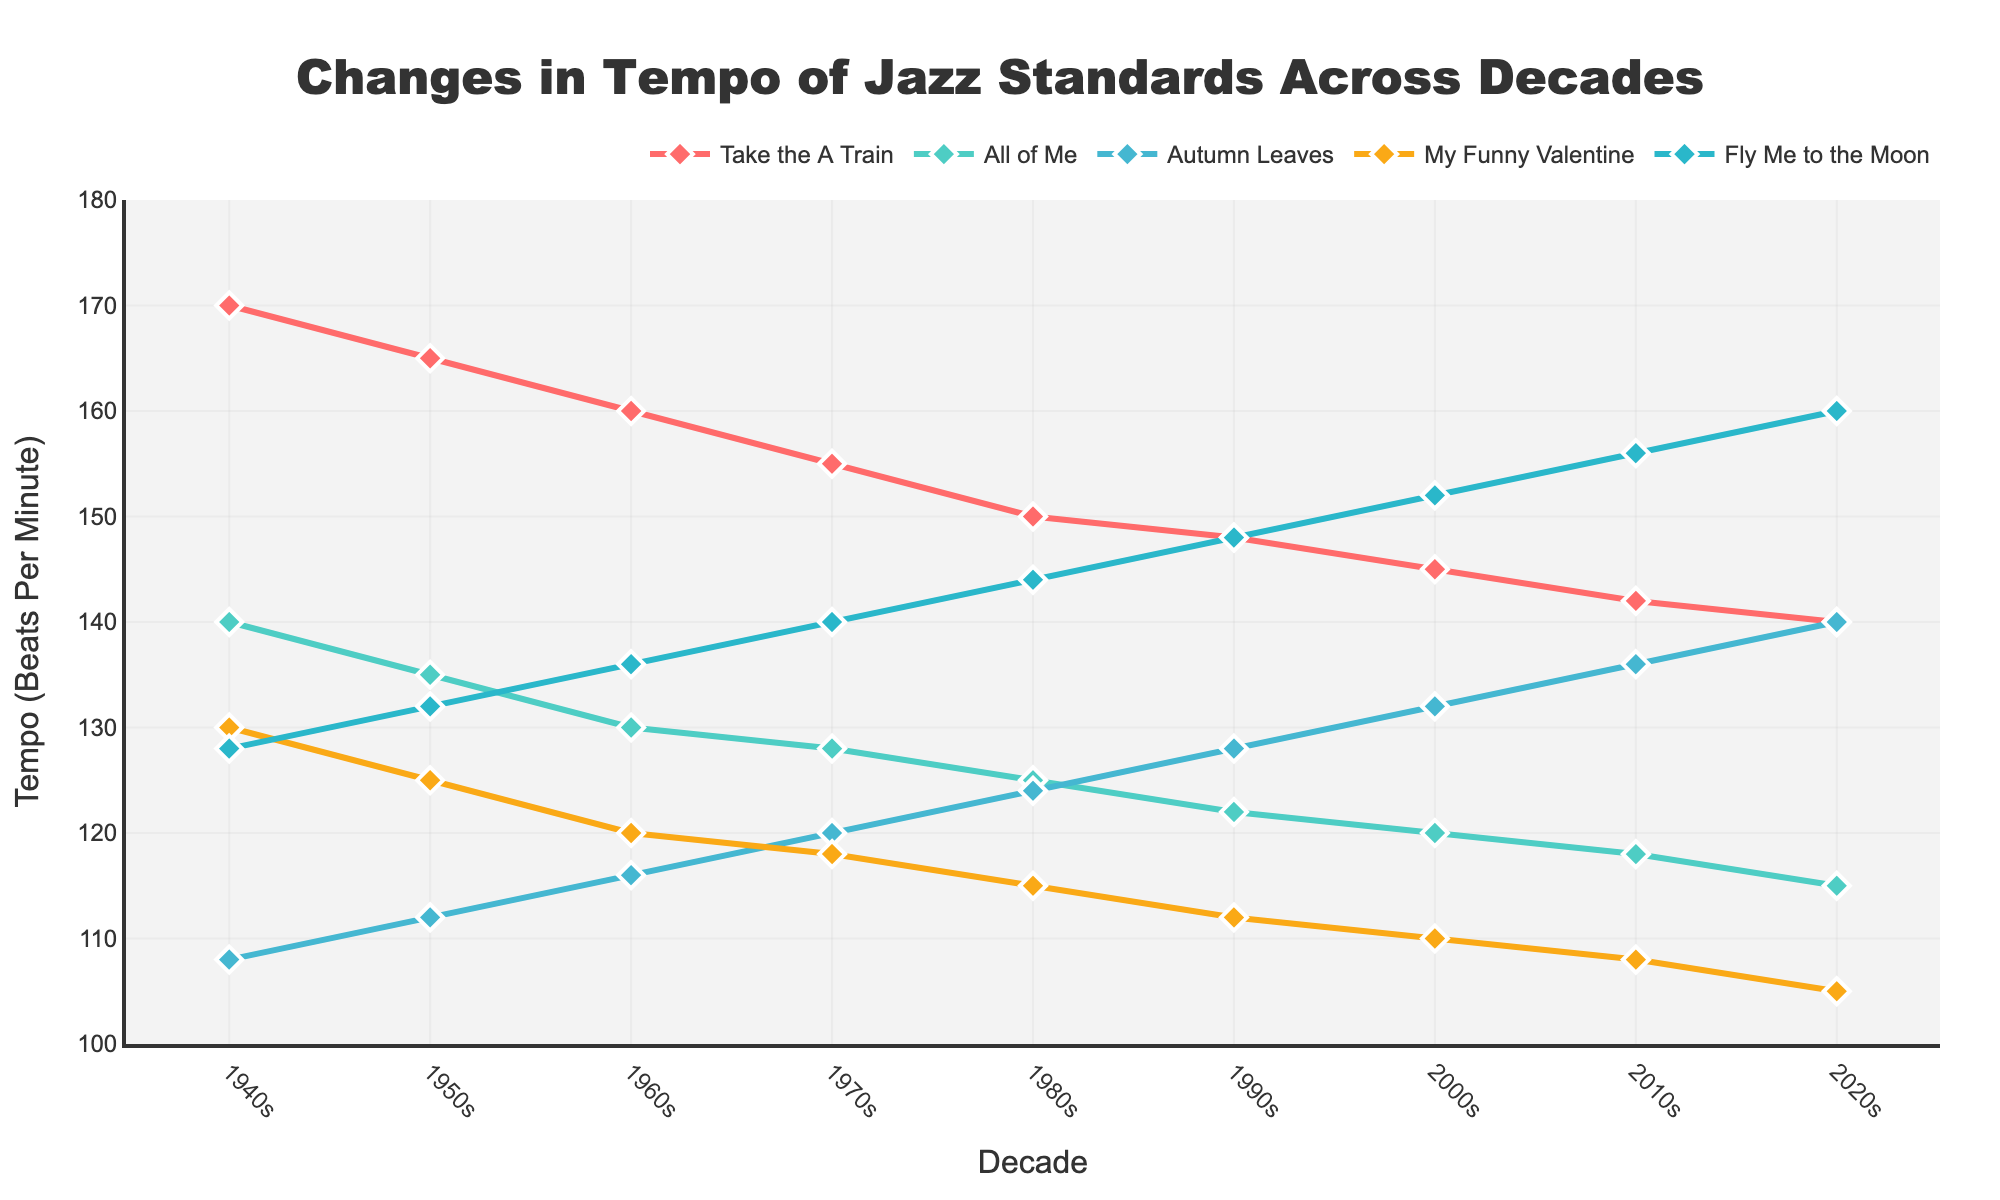What's the trend in the tempo of "Take the A Train" over the decades? By observing the plot line for "Take the A Train", we can see its tempo decreases gradually from the 1940s to the 2020s. It starts at 170 BPM in the 1940s and goes down to 140 BPM in the 2020s.
Answer: Decreasing Which song had the most significant increase in tempo from the 1940s to the 2020s? To find the song with the most significant increase, we need to compare the tempo values from the 1940s and the 2020s. "Fly Me to the Moon" increases from 128 BPM in the 1940s to 160 BPM in the 2020s.
Answer: Fly Me to the Moon How does the tempo of "My Funny Valentine" in the 1970s compare to that in the 2020s? The tempo of "My Funny Valentine" in the 1970s is 118 BPM, and in the 2020s it is 105 BPM. This shows a decrease.
Answer: Decreased What is the average tempo of "All of Me" over the decades? To find the average, we sum the tempo values for each decade for "All of Me" (140 + 135 + 130 + 128 + 125 + 122 + 120 + 118 + 115) and divide by the number of decades (9). (140 + 135 + 130 + 128 + 125 + 122 + 120 + 118 + 115) / 9 = 126.44 BPM.
Answer: 126.44 BPM Which song has the slowest tempo in the 2000s? By looking at the tempos in the 2000s column, "My Funny Valentine" has the slowest tempo at 110 BPM.
Answer: My Funny Valentine Compare the change in tempo of "Autumn Leaves" and "Fly Me to the Moon" from the 1950s to the 2010s. Which song has a greater change in tempo? "Autumn Leaves" changes from 112 BPM in the 1950s to 136 BPM in the 2010s, a change of 24 BPM. "Fly Me to the Moon" changes from 132 BPM to 156 BPM, a change of 24 BPM. Both songs have the same change in tempo from the 1950s to the 2010s.
Answer: Both songs have the same change What is the median tempo of "Take the A Train" over the decades? To determine the median, we list the tempos: 170, 165, 160, 155, 150, 148, 145, 142, 140. The median is the middle value, which is 155.
Answer: 155 BPM Which decade sees "Autumn Leaves" reaching its highest tempo? According to the plot, "Autumn Leaves" reaches its highest tempo of 140 BPM in the 2020s.
Answer: 2020s Analyzing the visual attributes, which color line represents "Fly Me to the Moon"? By examining the color legend, "Fly Me to the Moon" is represented by the blue line.
Answer: Blue 